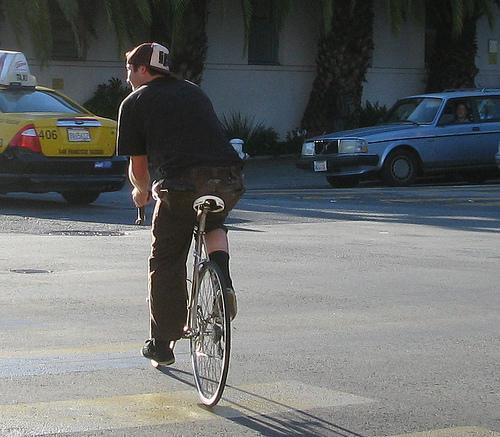How many people are visible?
Give a very brief answer. 2. How many fire hydrants are visible?
Give a very brief answer. 1. How many people are driving motors?
Give a very brief answer. 0. 